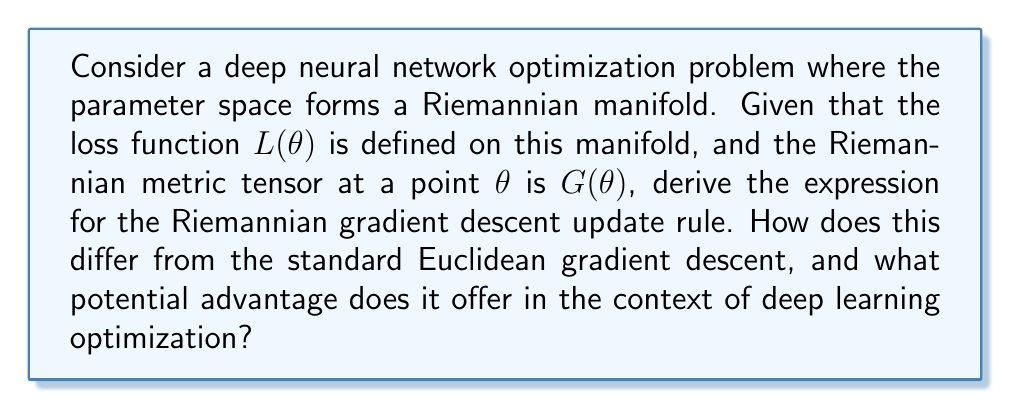Give your solution to this math problem. To solve this problem, we'll follow these steps:

1) In Euclidean space, the standard gradient descent update rule is:

   $$\theta_{t+1} = \theta_t - \eta \nabla L(\theta_t)$$

   where $\eta$ is the learning rate and $\nabla L(\theta_t)$ is the Euclidean gradient.

2) In Riemannian geometry, we need to consider the manifold structure. The Riemannian gradient is defined as:

   $$\text{grad} L(\theta) = G^{-1}(\theta) \nabla L(\theta)$$

   where $G^{-1}(\theta)$ is the inverse of the metric tensor.

3) The Riemannian gradient descent update rule becomes:

   $$\theta_{t+1} = \theta_t - \eta G^{-1}(\theta_t) \nabla L(\theta_t)$$

4) The key difference is the inclusion of $G^{-1}(\theta_t)$, which accounts for the curvature of the parameter space.

5) In the context of deep learning optimization, this approach offers several potential advantages:

   a) It can help navigate the optimization landscape more efficiently, especially in areas of high curvature.
   
   b) It can lead to improved convergence rates, particularly for ill-conditioned problems.
   
   c) It can provide a form of natural regularization, as the metric tensor adapts to the local geometry of the parameter space.

6) For deep learning architectures, especially those involving sequence modeling, this approach can be particularly beneficial when dealing with long-range dependencies or complex parameter interactions.
Answer: $$\theta_{t+1} = \theta_t - \eta G^{-1}(\theta_t) \nabla L(\theta_t)$$ 